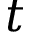<formula> <loc_0><loc_0><loc_500><loc_500>t</formula> 